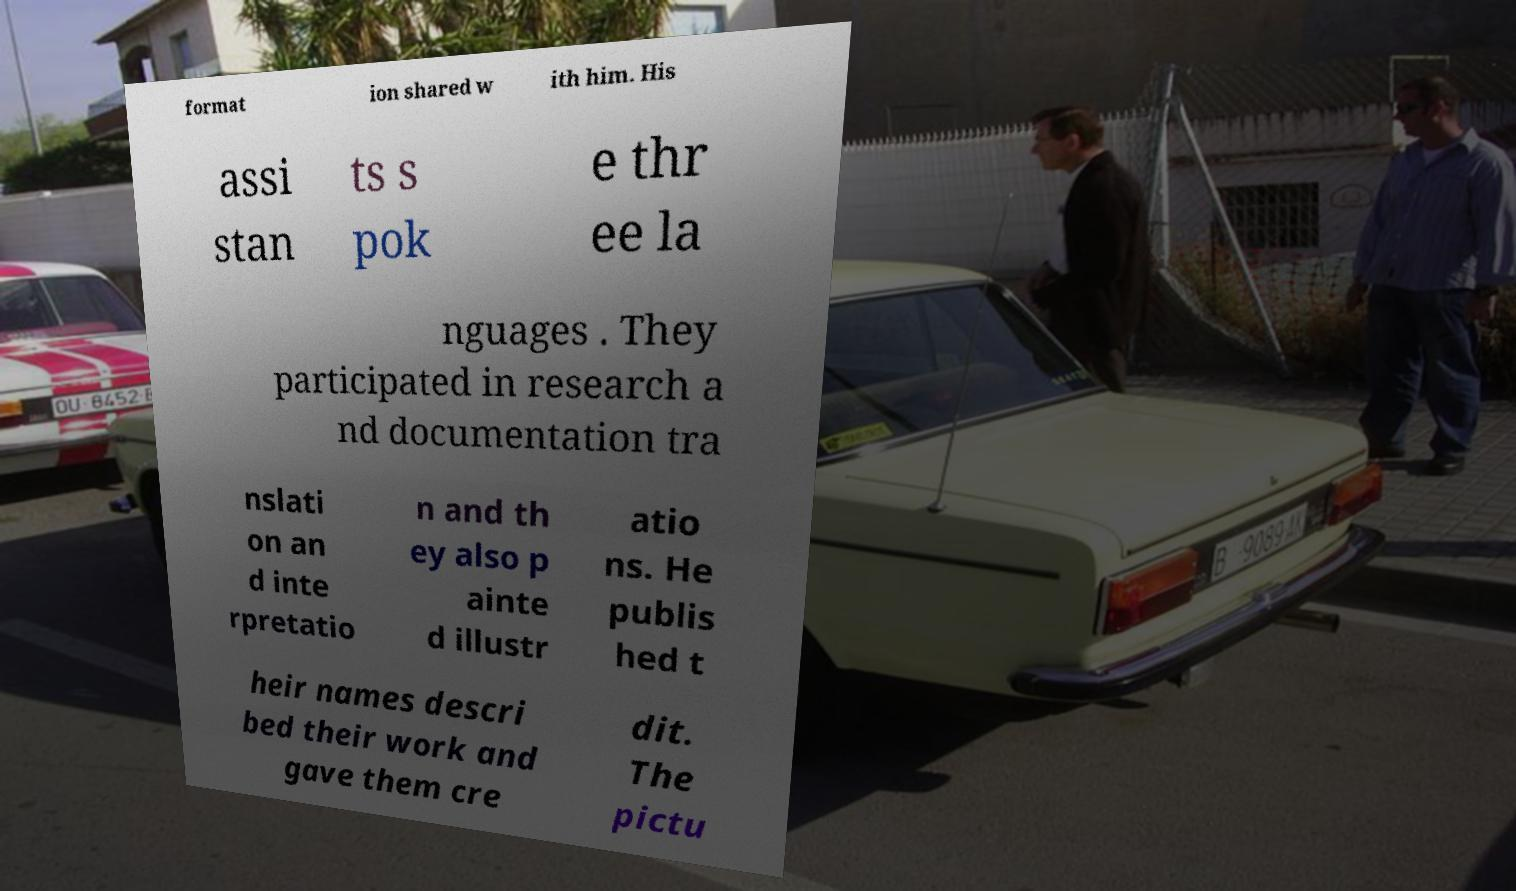I need the written content from this picture converted into text. Can you do that? format ion shared w ith him. His assi stan ts s pok e thr ee la nguages . They participated in research a nd documentation tra nslati on an d inte rpretatio n and th ey also p ainte d illustr atio ns. He publis hed t heir names descri bed their work and gave them cre dit. The pictu 